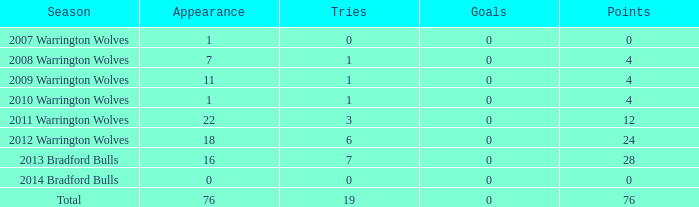When the number of goals is more than 0, what is the total appearance count? None. 